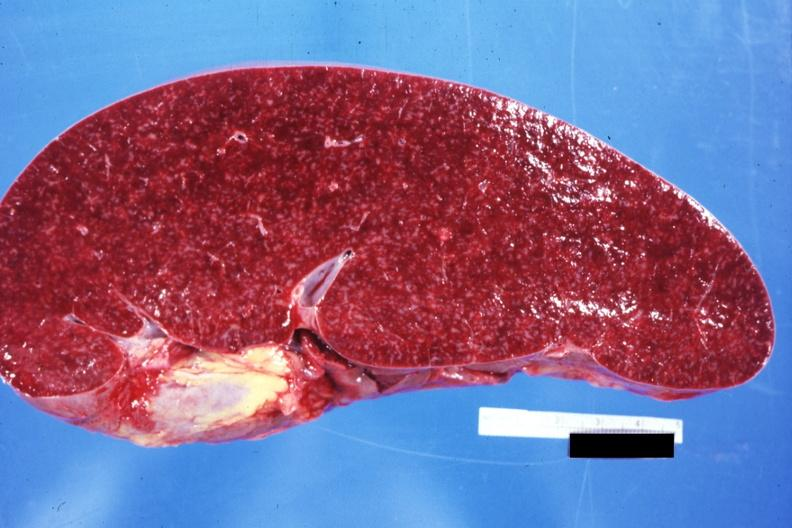s gout present?
Answer the question using a single word or phrase. No 